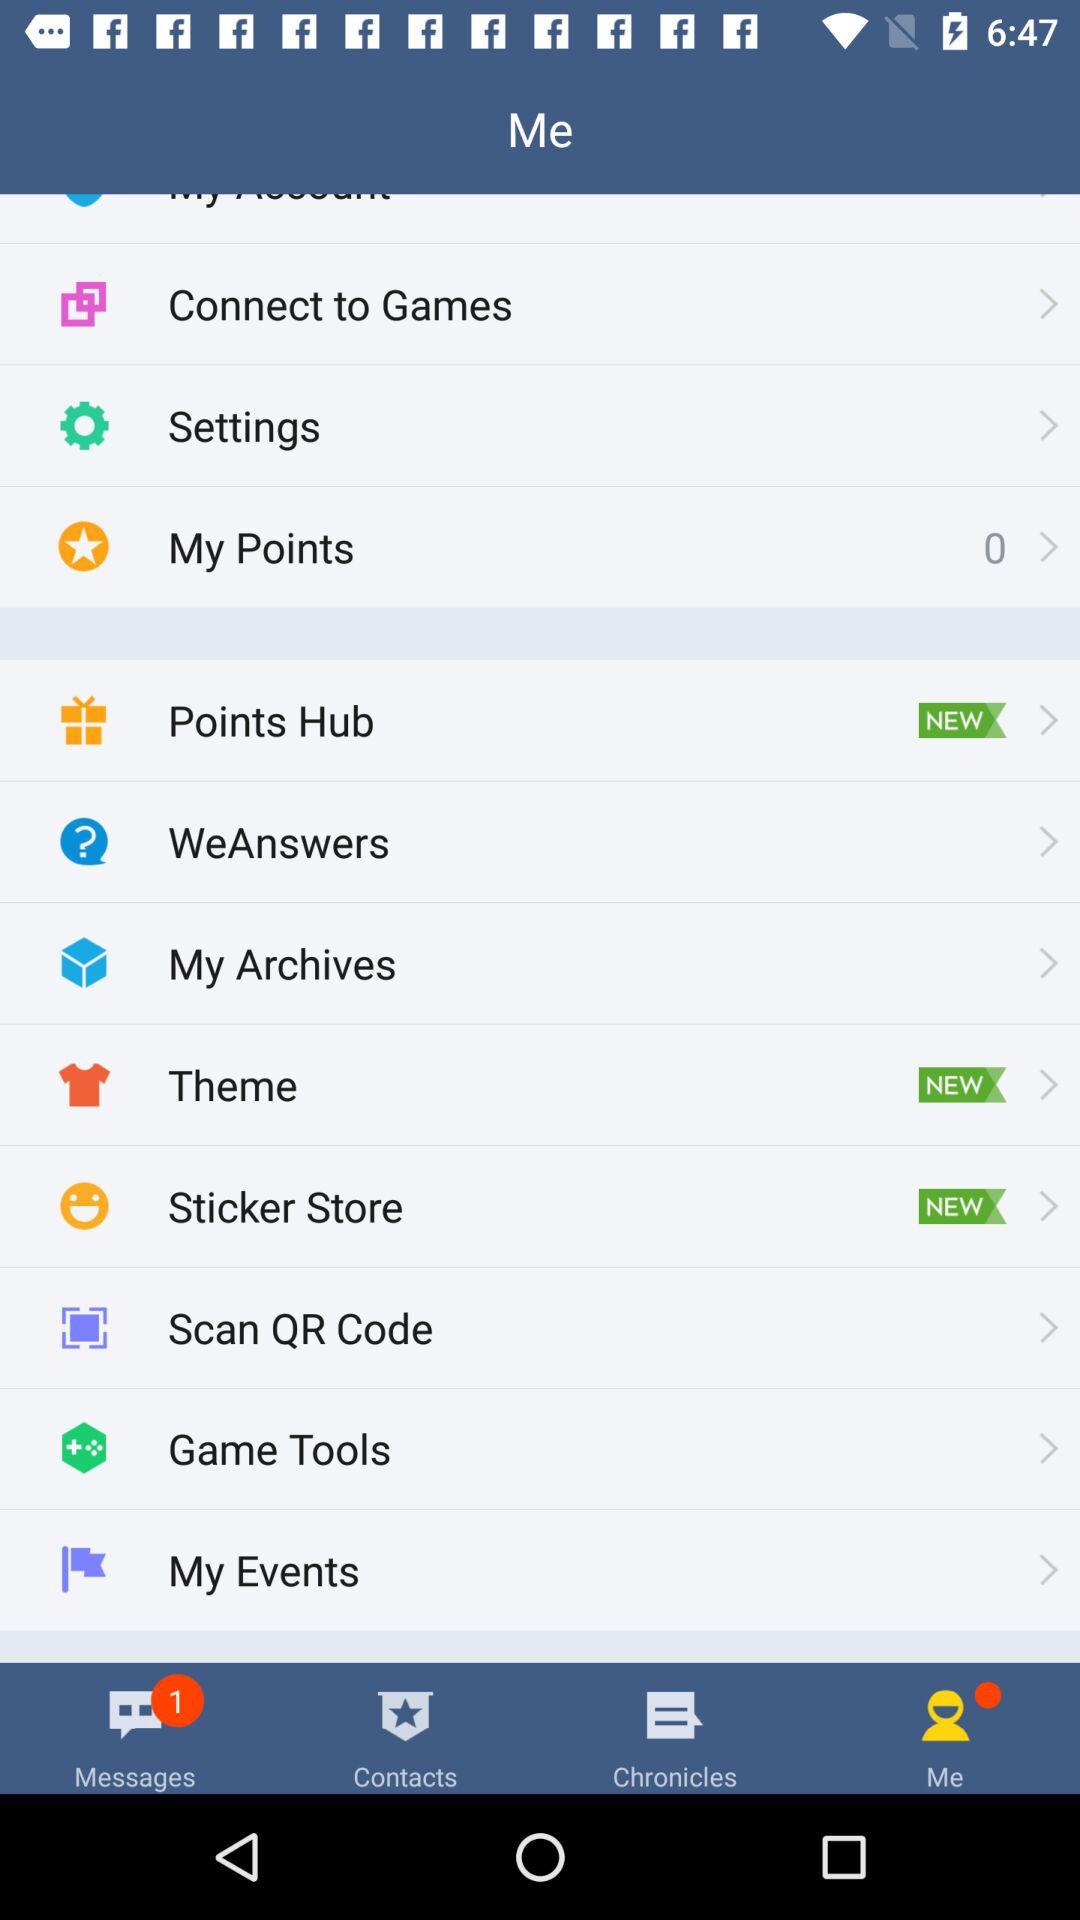How many unread messages are there? There is 1 unread message. 